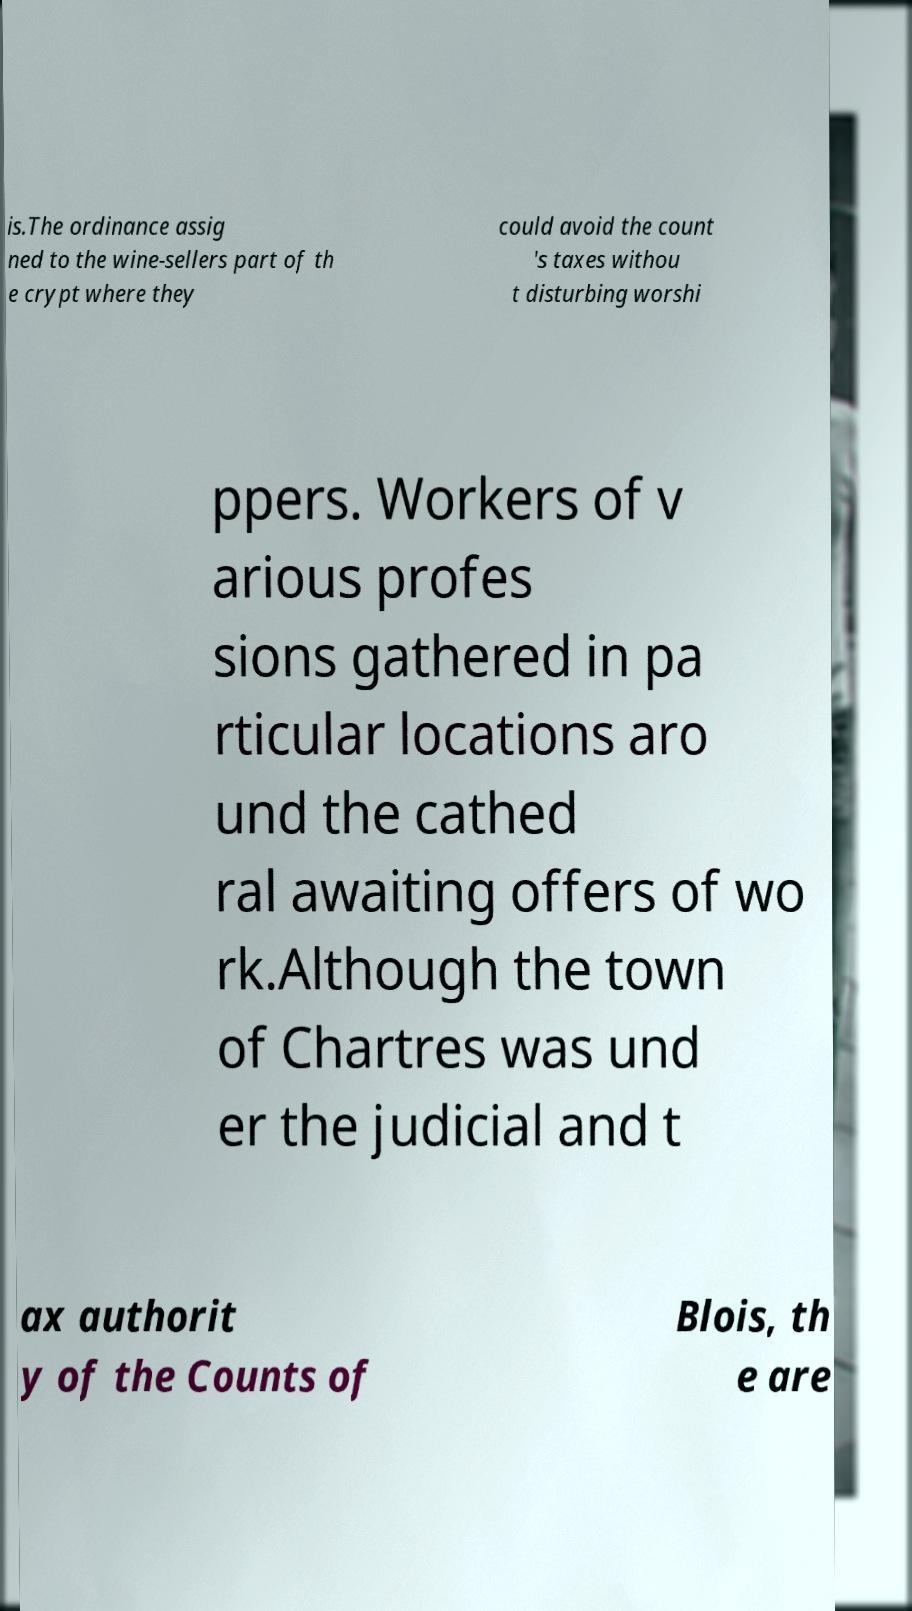Can you read and provide the text displayed in the image?This photo seems to have some interesting text. Can you extract and type it out for me? is.The ordinance assig ned to the wine-sellers part of th e crypt where they could avoid the count 's taxes withou t disturbing worshi ppers. Workers of v arious profes sions gathered in pa rticular locations aro und the cathed ral awaiting offers of wo rk.Although the town of Chartres was und er the judicial and t ax authorit y of the Counts of Blois, th e are 